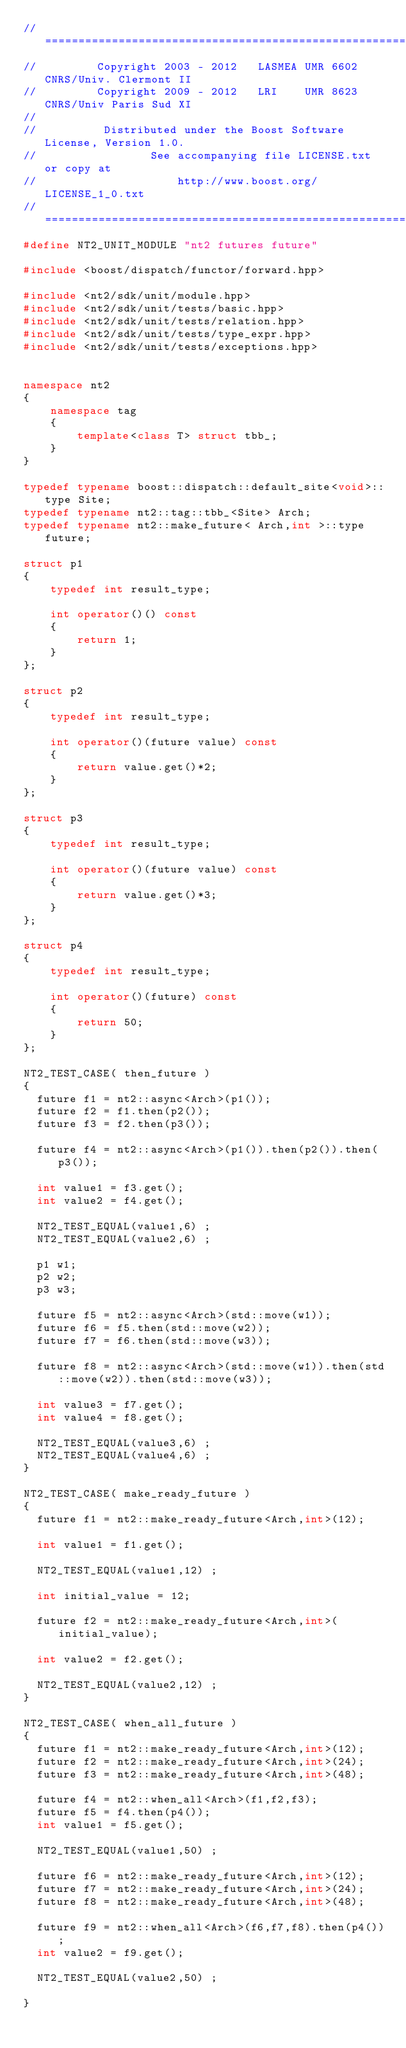<code> <loc_0><loc_0><loc_500><loc_500><_C++_>//==============================================================================
//         Copyright 2003 - 2012   LASMEA UMR 6602 CNRS/Univ. Clermont II
//         Copyright 2009 - 2012   LRI    UMR 8623 CNRS/Univ Paris Sud XI
//
//          Distributed under the Boost Software License, Version 1.0.
//                 See accompanying file LICENSE.txt or copy at
//                     http://www.boost.org/LICENSE_1_0.txt
//==============================================================================
#define NT2_UNIT_MODULE "nt2 futures future"

#include <boost/dispatch/functor/forward.hpp>

#include <nt2/sdk/unit/module.hpp>
#include <nt2/sdk/unit/tests/basic.hpp>
#include <nt2/sdk/unit/tests/relation.hpp>
#include <nt2/sdk/unit/tests/type_expr.hpp>
#include <nt2/sdk/unit/tests/exceptions.hpp>


namespace nt2
{
    namespace tag
    {
        template<class T> struct tbb_;
    }
}

typedef typename boost::dispatch::default_site<void>::type Site;
typedef typename nt2::tag::tbb_<Site> Arch;
typedef typename nt2::make_future< Arch,int >::type future;

struct p1
{
    typedef int result_type;

    int operator()() const
    {
        return 1;
    }
};

struct p2
{
    typedef int result_type;

    int operator()(future value) const
    {
        return value.get()*2;
    }
};

struct p3
{
    typedef int result_type;

    int operator()(future value) const
    {
        return value.get()*3;
    }
};

struct p4
{
    typedef int result_type;

    int operator()(future) const
    {
        return 50;
    }
};

NT2_TEST_CASE( then_future )
{
  future f1 = nt2::async<Arch>(p1());
  future f2 = f1.then(p2());
  future f3 = f2.then(p3());

  future f4 = nt2::async<Arch>(p1()).then(p2()).then(p3());

  int value1 = f3.get();
  int value2 = f4.get();

  NT2_TEST_EQUAL(value1,6) ;
  NT2_TEST_EQUAL(value2,6) ;

  p1 w1;
  p2 w2;
  p3 w3;

  future f5 = nt2::async<Arch>(std::move(w1));
  future f6 = f5.then(std::move(w2));
  future f7 = f6.then(std::move(w3));

  future f8 = nt2::async<Arch>(std::move(w1)).then(std::move(w2)).then(std::move(w3));

  int value3 = f7.get();
  int value4 = f8.get();

  NT2_TEST_EQUAL(value3,6) ;
  NT2_TEST_EQUAL(value4,6) ;
}

NT2_TEST_CASE( make_ready_future )
{
  future f1 = nt2::make_ready_future<Arch,int>(12);

  int value1 = f1.get();

  NT2_TEST_EQUAL(value1,12) ;

  int initial_value = 12;

  future f2 = nt2::make_ready_future<Arch,int>(initial_value);

  int value2 = f2.get();

  NT2_TEST_EQUAL(value2,12) ;
}

NT2_TEST_CASE( when_all_future )
{
  future f1 = nt2::make_ready_future<Arch,int>(12);
  future f2 = nt2::make_ready_future<Arch,int>(24);
  future f3 = nt2::make_ready_future<Arch,int>(48);

  future f4 = nt2::when_all<Arch>(f1,f2,f3);
  future f5 = f4.then(p4());
  int value1 = f5.get();

  NT2_TEST_EQUAL(value1,50) ;

  future f6 = nt2::make_ready_future<Arch,int>(12);
  future f7 = nt2::make_ready_future<Arch,int>(24);
  future f8 = nt2::make_ready_future<Arch,int>(48);

  future f9 = nt2::when_all<Arch>(f6,f7,f8).then(p4());
  int value2 = f9.get();

  NT2_TEST_EQUAL(value2,50) ;

}
</code> 